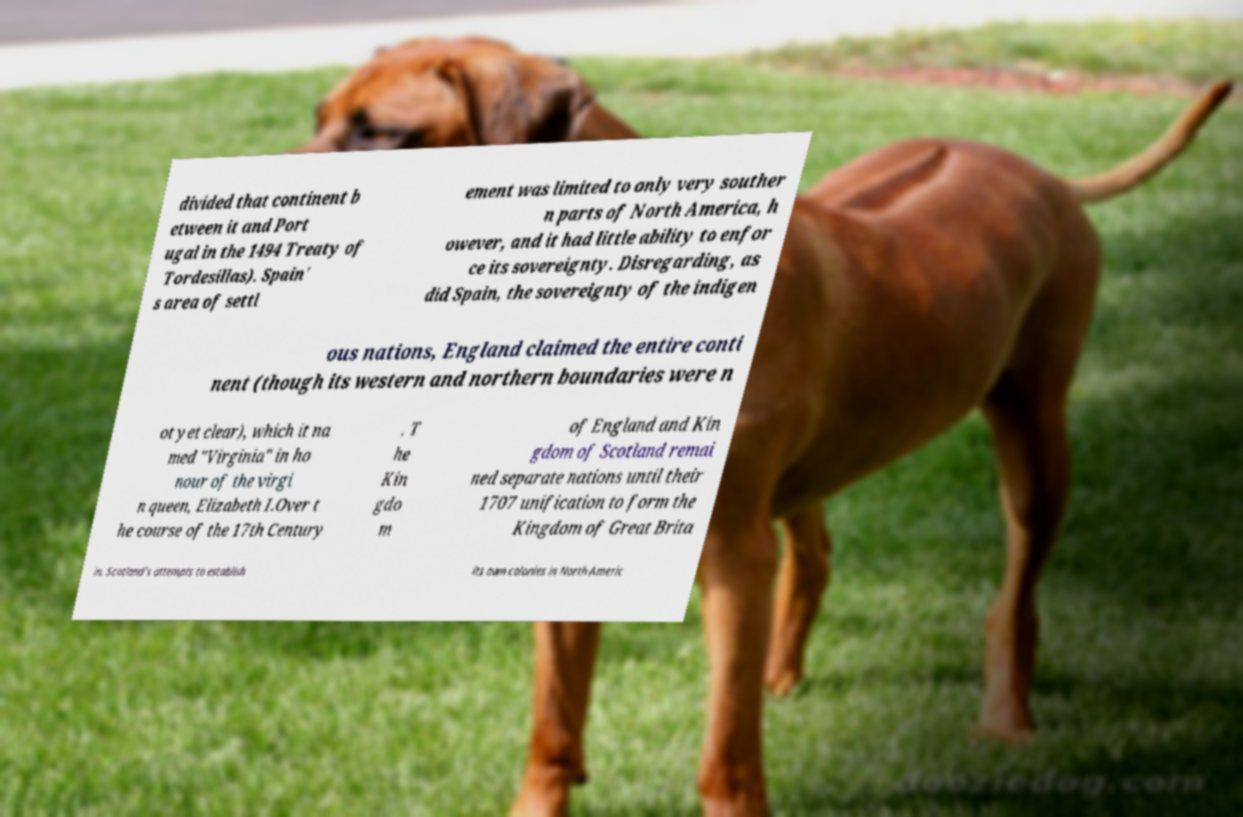Please read and relay the text visible in this image. What does it say? divided that continent b etween it and Port ugal in the 1494 Treaty of Tordesillas). Spain' s area of settl ement was limited to only very souther n parts of North America, h owever, and it had little ability to enfor ce its sovereignty. Disregarding, as did Spain, the sovereignty of the indigen ous nations, England claimed the entire conti nent (though its western and northern boundaries were n ot yet clear), which it na med "Virginia" in ho nour of the virgi n queen, Elizabeth I.Over t he course of the 17th Century . T he Kin gdo m of England and Kin gdom of Scotland remai ned separate nations until their 1707 unification to form the Kingdom of Great Brita in. Scotland's attempts to establish its own colonies in North Americ 